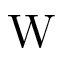Convert formula to latex. <formula><loc_0><loc_0><loc_500><loc_500>W</formula> 